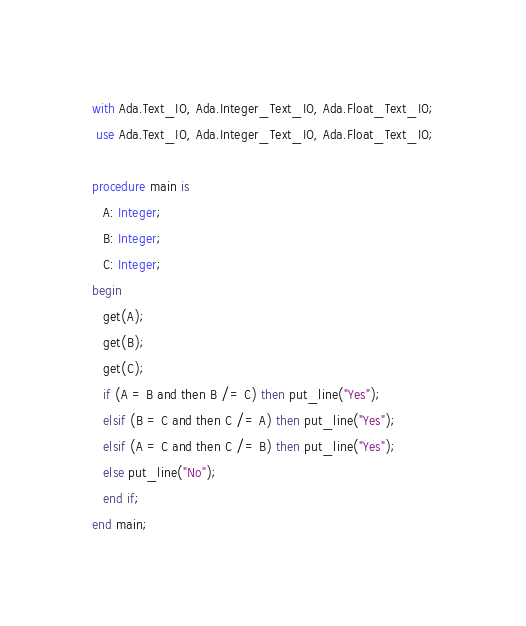<code> <loc_0><loc_0><loc_500><loc_500><_Ada_>with Ada.Text_IO, Ada.Integer_Text_IO, Ada.Float_Text_IO;
 use Ada.Text_IO, Ada.Integer_Text_IO, Ada.Float_Text_IO;

procedure main is
   A: Integer;
   B: Integer;
   C: Integer;
begin
   get(A);
   get(B);
   get(C);
   if (A = B and then B /= C) then put_line("Yes");
   elsif (B = C and then C /= A) then put_line("Yes");
   elsif (A = C and then C /= B) then put_line("Yes");
   else put_line("No");
   end if;
end main;</code> 